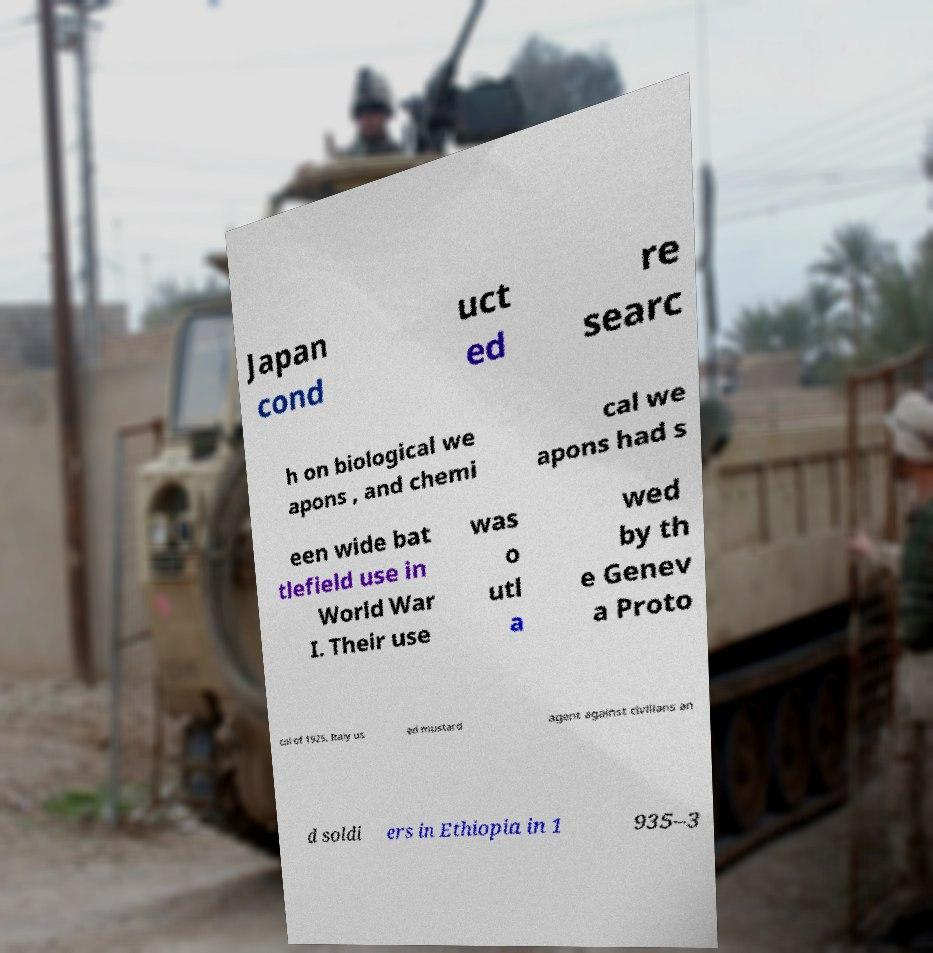I need the written content from this picture converted into text. Can you do that? Japan cond uct ed re searc h on biological we apons , and chemi cal we apons had s een wide bat tlefield use in World War I. Their use was o utl a wed by th e Genev a Proto col of 1925. Italy us ed mustard agent against civilians an d soldi ers in Ethiopia in 1 935–3 